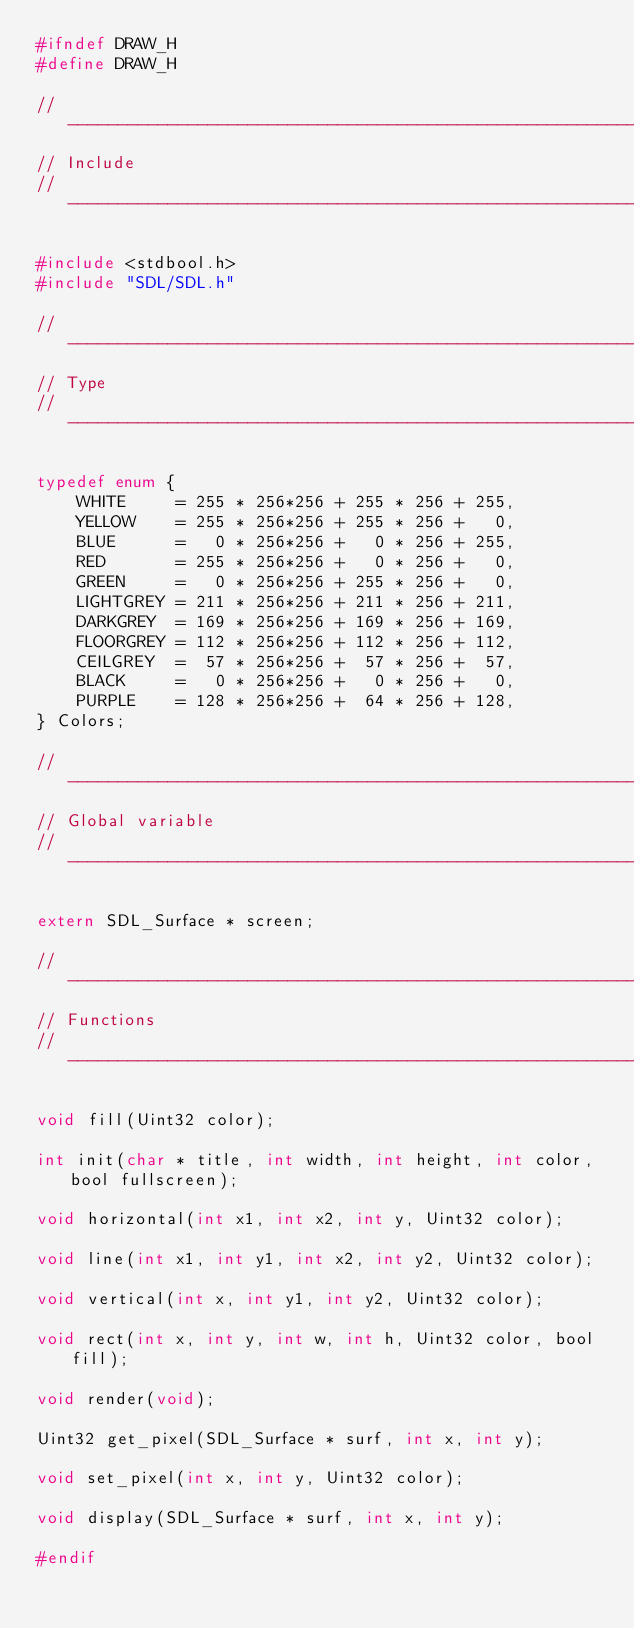Convert code to text. <code><loc_0><loc_0><loc_500><loc_500><_C_>#ifndef DRAW_H
#define DRAW_H

//-----------------------------------------------------------------------------
// Include
//-----------------------------------------------------------------------------

#include <stdbool.h>
#include "SDL/SDL.h"

//-----------------------------------------------------------------------------
// Type
//-----------------------------------------------------------------------------

typedef enum {
    WHITE     = 255 * 256*256 + 255 * 256 + 255,
    YELLOW    = 255 * 256*256 + 255 * 256 +   0,
    BLUE      =   0 * 256*256 +   0 * 256 + 255,
    RED       = 255 * 256*256 +   0 * 256 +   0,
    GREEN     =   0 * 256*256 + 255 * 256 +   0,
    LIGHTGREY = 211 * 256*256 + 211 * 256 + 211,
    DARKGREY  = 169 * 256*256 + 169 * 256 + 169,
    FLOORGREY = 112 * 256*256 + 112 * 256 + 112,
    CEILGREY  =  57 * 256*256 +  57 * 256 +  57,
    BLACK     =   0 * 256*256 +   0 * 256 +   0,
    PURPLE    = 128 * 256*256 +  64 * 256 + 128,
} Colors;

//-----------------------------------------------------------------------------
// Global variable
//-----------------------------------------------------------------------------

extern SDL_Surface * screen;

//-----------------------------------------------------------------------------
// Functions
//-----------------------------------------------------------------------------

void fill(Uint32 color);

int init(char * title, int width, int height, int color, bool fullscreen);

void horizontal(int x1, int x2, int y, Uint32 color);

void line(int x1, int y1, int x2, int y2, Uint32 color);

void vertical(int x, int y1, int y2, Uint32 color);

void rect(int x, int y, int w, int h, Uint32 color, bool fill);

void render(void);

Uint32 get_pixel(SDL_Surface * surf, int x, int y);

void set_pixel(int x, int y, Uint32 color);

void display(SDL_Surface * surf, int x, int y);

#endif
</code> 